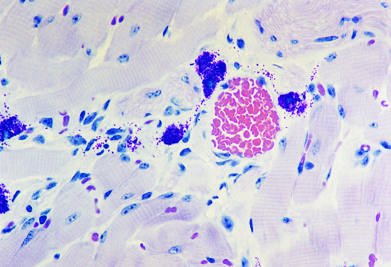what is characterized by vasodilation, congestion, and edema?
Answer the question using a single word or phrase. The immediate reaction 